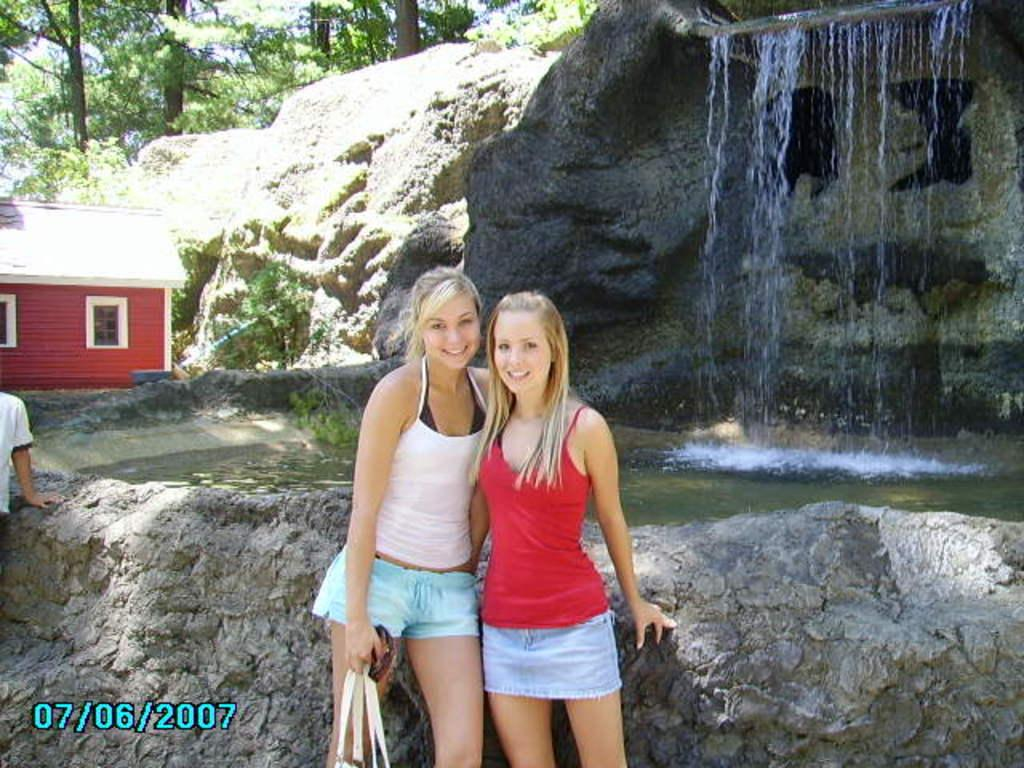<image>
Present a compact description of the photo's key features. Two girls posing, with a date stamp of July 6 2007. 